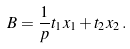Convert formula to latex. <formula><loc_0><loc_0><loc_500><loc_500>B = \frac { 1 } { p } t _ { 1 } x _ { 1 } + t _ { 2 } x _ { 2 } \, .</formula> 